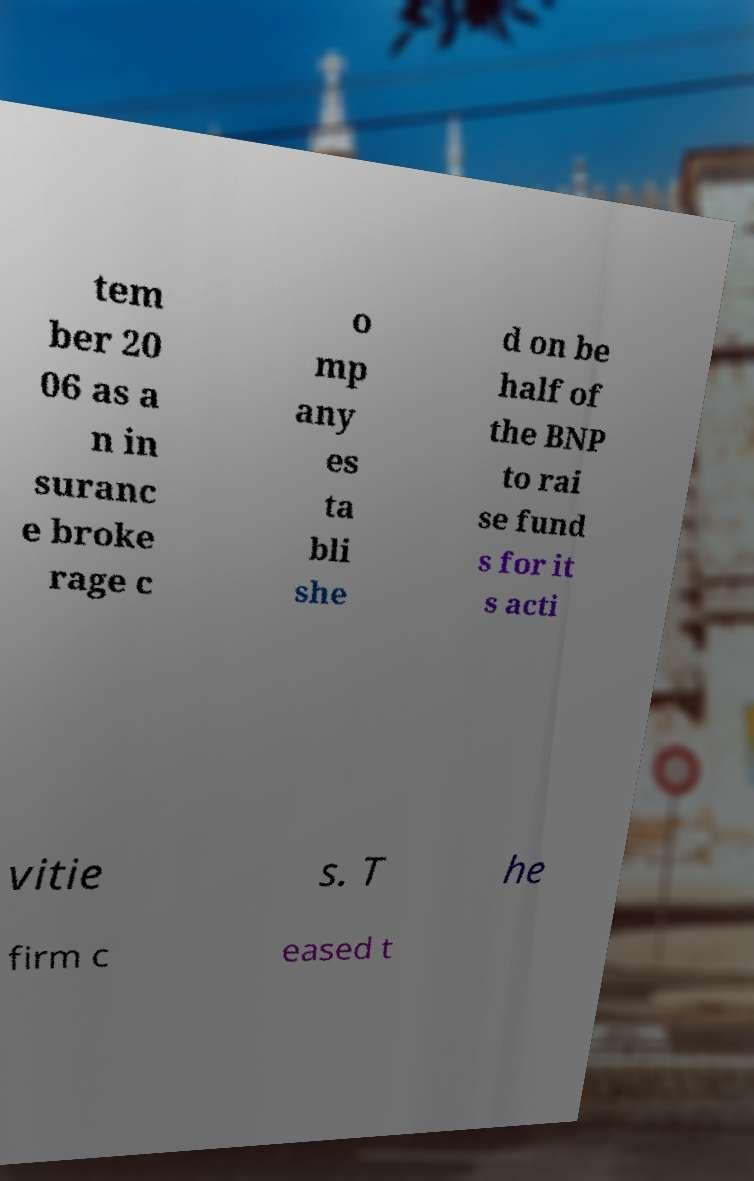What messages or text are displayed in this image? I need them in a readable, typed format. tem ber 20 06 as a n in suranc e broke rage c o mp any es ta bli she d on be half of the BNP to rai se fund s for it s acti vitie s. T he firm c eased t 